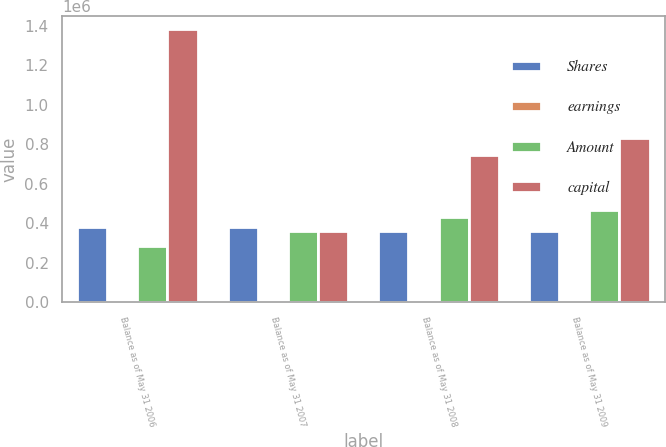Convert chart. <chart><loc_0><loc_0><loc_500><loc_500><stacked_bar_chart><ecel><fcel>Balance as of May 31 2006<fcel>Balance as of May 31 2007<fcel>Balance as of May 31 2008<fcel>Balance as of May 31 2009<nl><fcel>Shares<fcel>380303<fcel>382151<fcel>360500<fcel>360976<nl><fcel>earnings<fcel>3803<fcel>3822<fcel>3605<fcel>3610<nl><fcel>Amount<fcel>284395<fcel>362982<fcel>431639<fcel>466427<nl><fcel>capital<fcel>1.38097e+06<fcel>362982<fcel>745351<fcel>829501<nl></chart> 